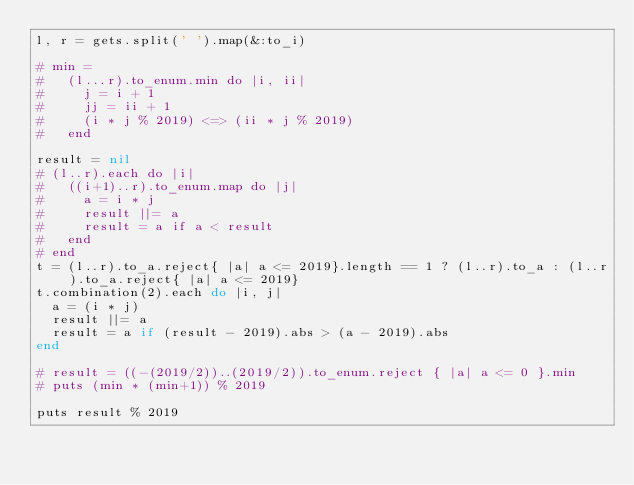<code> <loc_0><loc_0><loc_500><loc_500><_Ruby_>l, r = gets.split(' ').map(&:to_i)

# min =
#   (l...r).to_enum.min do |i, ii|
#     j = i + 1
#     jj = ii + 1
#     (i * j % 2019) <=> (ii * j % 2019)
#   end

result = nil
# (l..r).each do |i|
#   ((i+1)..r).to_enum.map do |j|
#     a = i * j
#     result ||= a
#     result = a if a < result
#   end
# end
t = (l..r).to_a.reject{ |a| a <= 2019}.length == 1 ? (l..r).to_a : (l..r).to_a.reject{ |a| a <= 2019}
t.combination(2).each do |i, j|
  a = (i * j)
  result ||= a
  result = a if (result - 2019).abs > (a - 2019).abs
end

# result = ((-(2019/2))..(2019/2)).to_enum.reject { |a| a <= 0 }.min
# puts (min * (min+1)) % 2019

puts result % 2019</code> 